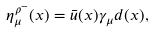<formula> <loc_0><loc_0><loc_500><loc_500>\eta _ { \mu } ^ { \rho ^ { - } } ( x ) = \bar { u } ( x ) \gamma _ { \mu } d ( x ) ,</formula> 